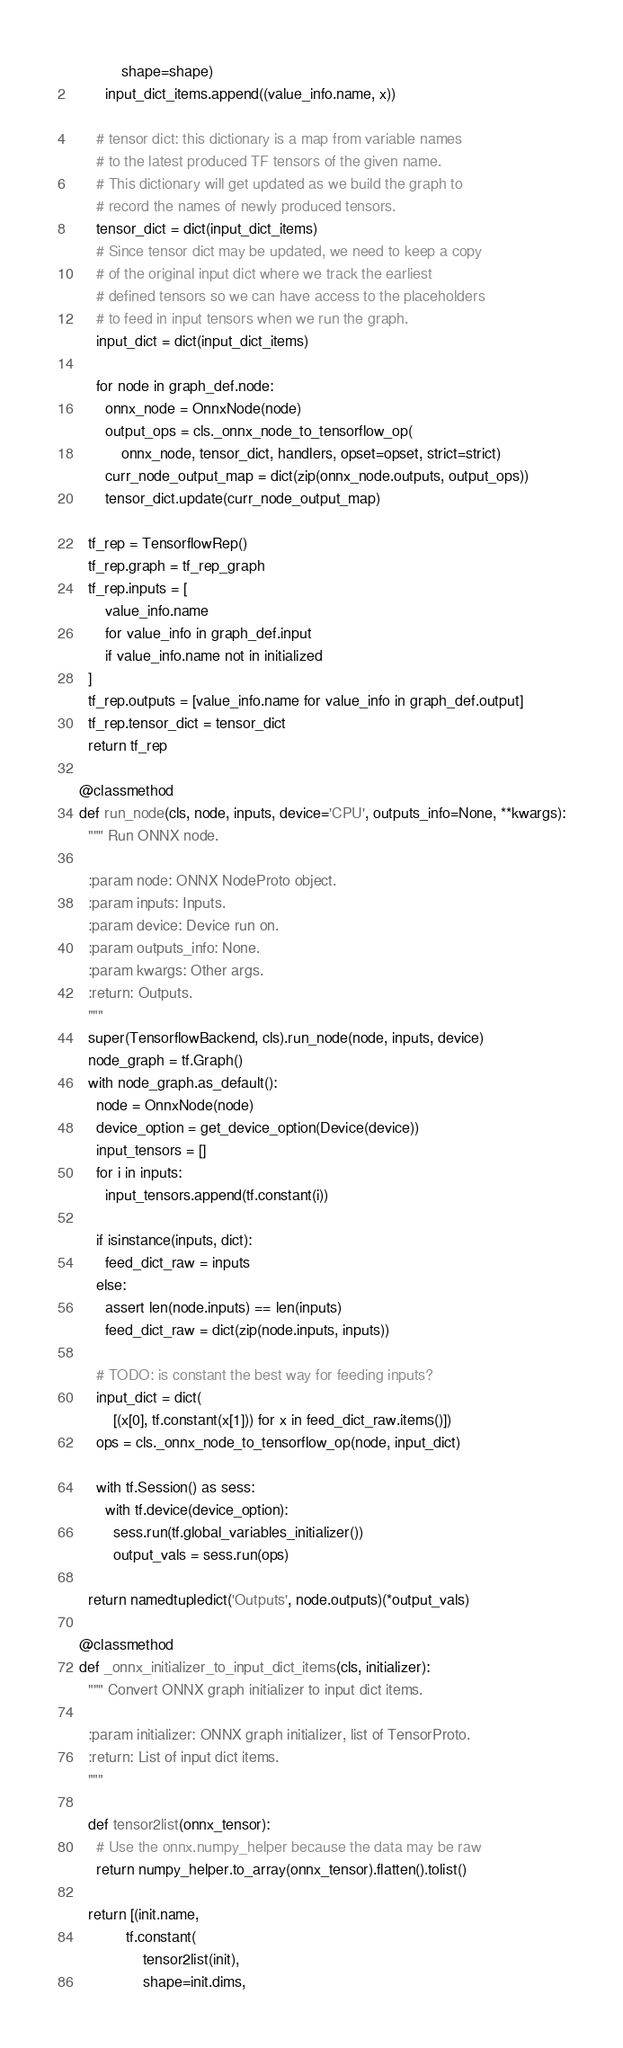<code> <loc_0><loc_0><loc_500><loc_500><_Python_>            shape=shape)
        input_dict_items.append((value_info.name, x))

      # tensor dict: this dictionary is a map from variable names
      # to the latest produced TF tensors of the given name.
      # This dictionary will get updated as we build the graph to
      # record the names of newly produced tensors.
      tensor_dict = dict(input_dict_items)
      # Since tensor dict may be updated, we need to keep a copy
      # of the original input dict where we track the earliest
      # defined tensors so we can have access to the placeholders
      # to feed in input tensors when we run the graph.
      input_dict = dict(input_dict_items)

      for node in graph_def.node:
        onnx_node = OnnxNode(node)
        output_ops = cls._onnx_node_to_tensorflow_op(
            onnx_node, tensor_dict, handlers, opset=opset, strict=strict)
        curr_node_output_map = dict(zip(onnx_node.outputs, output_ops))
        tensor_dict.update(curr_node_output_map)

    tf_rep = TensorflowRep()
    tf_rep.graph = tf_rep_graph
    tf_rep.inputs = [
        value_info.name
        for value_info in graph_def.input
        if value_info.name not in initialized
    ]
    tf_rep.outputs = [value_info.name for value_info in graph_def.output]
    tf_rep.tensor_dict = tensor_dict
    return tf_rep

  @classmethod
  def run_node(cls, node, inputs, device='CPU', outputs_info=None, **kwargs):
    """ Run ONNX node.

    :param node: ONNX NodeProto object.
    :param inputs: Inputs.
    :param device: Device run on.
    :param outputs_info: None.
    :param kwargs: Other args.
    :return: Outputs.
    """
    super(TensorflowBackend, cls).run_node(node, inputs, device)
    node_graph = tf.Graph()
    with node_graph.as_default():
      node = OnnxNode(node)
      device_option = get_device_option(Device(device))
      input_tensors = []
      for i in inputs:
        input_tensors.append(tf.constant(i))

      if isinstance(inputs, dict):
        feed_dict_raw = inputs
      else:
        assert len(node.inputs) == len(inputs)
        feed_dict_raw = dict(zip(node.inputs, inputs))

      # TODO: is constant the best way for feeding inputs?
      input_dict = dict(
          [(x[0], tf.constant(x[1])) for x in feed_dict_raw.items()])
      ops = cls._onnx_node_to_tensorflow_op(node, input_dict)

      with tf.Session() as sess:
        with tf.device(device_option):
          sess.run(tf.global_variables_initializer())
          output_vals = sess.run(ops)

    return namedtupledict('Outputs', node.outputs)(*output_vals)

  @classmethod
  def _onnx_initializer_to_input_dict_items(cls, initializer):
    """ Convert ONNX graph initializer to input dict items.

    :param initializer: ONNX graph initializer, list of TensorProto.
    :return: List of input dict items.
    """

    def tensor2list(onnx_tensor):
      # Use the onnx.numpy_helper because the data may be raw
      return numpy_helper.to_array(onnx_tensor).flatten().tolist()

    return [(init.name,
             tf.constant(
                 tensor2list(init),
                 shape=init.dims,</code> 